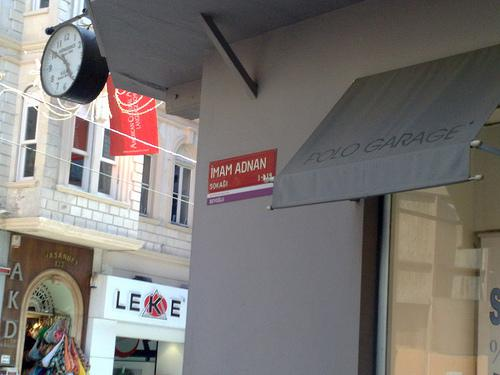Question: where is this picture being taken?
Choices:
A. On the beach.
B. On the street.
C. Outside of Polo Garage.
D. In front of the store.
Answer with the letter. Answer: C Question: what is above the telephone wires?
Choices:
A. The sky.
B. A building.
C. A clock.
D. Trees.
Answer with the letter. Answer: C Question: what does the red sign say?
Choices:
A. Imam Adnan.
B. Stop.
C. Yield.
D. No Exit.
Answer with the letter. Answer: A Question: when will it be 5:00?
Choices:
A. 20 minutes.
B. 2 hours.
C. 5 minutes.
D. Ten minutes.
Answer with the letter. Answer: D Question: what time does the clock read?
Choices:
A. 4:30.
B. 2:15.
C. 4:50.
D. 3:47.
Answer with the letter. Answer: C 